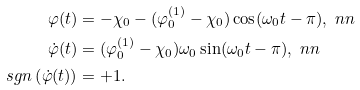<formula> <loc_0><loc_0><loc_500><loc_500>\varphi ( t ) & = - \chi _ { 0 } - ( \varphi ^ { ( 1 ) } _ { 0 } - \chi _ { 0 } ) \cos ( \omega _ { 0 } t - \pi ) , \ n n \\ \dot { \varphi } ( t ) & = ( \varphi ^ { ( 1 ) } _ { 0 } - \chi _ { 0 } ) \omega _ { 0 } \sin ( \omega _ { 0 } t - \pi ) , \ n n \\ s g n \left ( \dot { \varphi } ( t ) \right ) & = + 1 .</formula> 